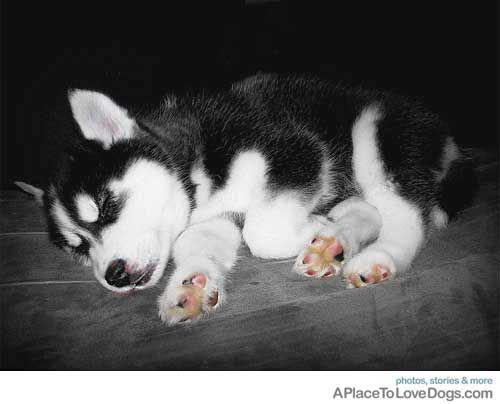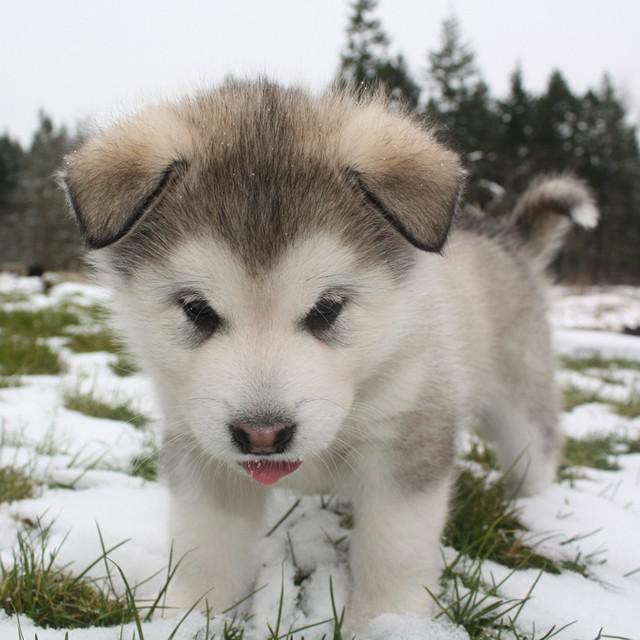The first image is the image on the left, the second image is the image on the right. Given the left and right images, does the statement "A dog is on its back." hold true? Answer yes or no. No. The first image is the image on the left, the second image is the image on the right. Evaluate the accuracy of this statement regarding the images: "Four canines are visible.". Is it true? Answer yes or no. No. 